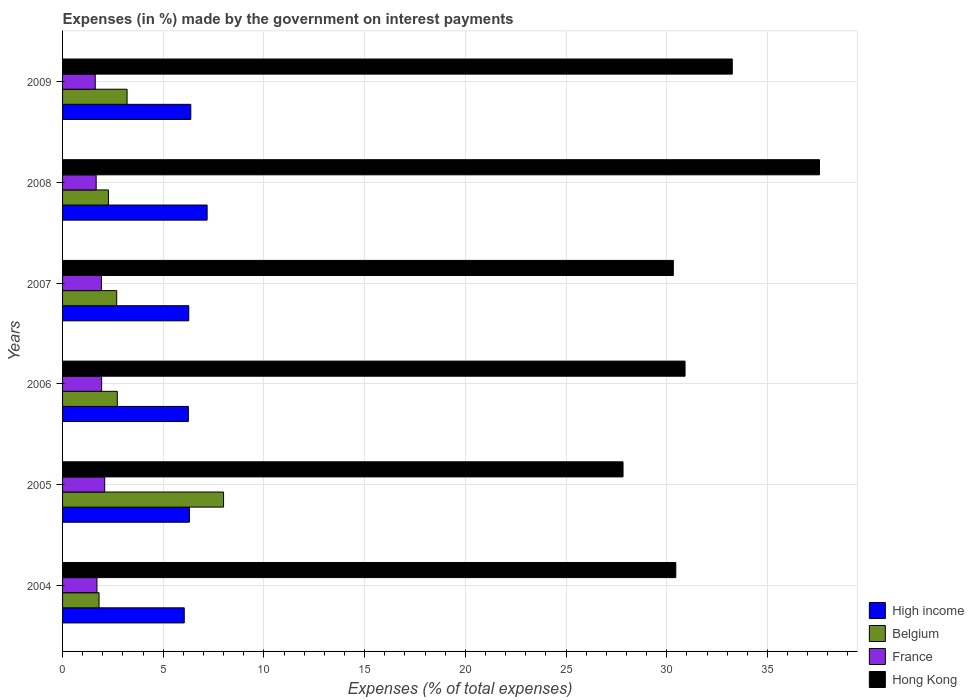Are the number of bars per tick equal to the number of legend labels?
Provide a succinct answer. Yes. How many bars are there on the 5th tick from the top?
Provide a short and direct response. 4. How many bars are there on the 2nd tick from the bottom?
Offer a very short reply. 4. What is the label of the 6th group of bars from the top?
Offer a very short reply. 2004. In how many cases, is the number of bars for a given year not equal to the number of legend labels?
Keep it short and to the point. 0. What is the percentage of expenses made by the government on interest payments in High income in 2004?
Your response must be concise. 6.04. Across all years, what is the maximum percentage of expenses made by the government on interest payments in High income?
Provide a short and direct response. 7.18. Across all years, what is the minimum percentage of expenses made by the government on interest payments in High income?
Keep it short and to the point. 6.04. What is the total percentage of expenses made by the government on interest payments in France in the graph?
Your response must be concise. 10.96. What is the difference between the percentage of expenses made by the government on interest payments in Belgium in 2004 and that in 2007?
Your response must be concise. -0.88. What is the difference between the percentage of expenses made by the government on interest payments in Hong Kong in 2004 and the percentage of expenses made by the government on interest payments in France in 2005?
Ensure brevity in your answer.  28.36. What is the average percentage of expenses made by the government on interest payments in Belgium per year?
Ensure brevity in your answer.  3.45. In the year 2004, what is the difference between the percentage of expenses made by the government on interest payments in High income and percentage of expenses made by the government on interest payments in Belgium?
Your answer should be very brief. 4.23. What is the ratio of the percentage of expenses made by the government on interest payments in High income in 2004 to that in 2006?
Give a very brief answer. 0.97. Is the difference between the percentage of expenses made by the government on interest payments in High income in 2004 and 2006 greater than the difference between the percentage of expenses made by the government on interest payments in Belgium in 2004 and 2006?
Your response must be concise. Yes. What is the difference between the highest and the second highest percentage of expenses made by the government on interest payments in Hong Kong?
Your response must be concise. 4.33. What is the difference between the highest and the lowest percentage of expenses made by the government on interest payments in France?
Provide a succinct answer. 0.47. Is it the case that in every year, the sum of the percentage of expenses made by the government on interest payments in Belgium and percentage of expenses made by the government on interest payments in Hong Kong is greater than the sum of percentage of expenses made by the government on interest payments in High income and percentage of expenses made by the government on interest payments in France?
Offer a very short reply. Yes. What does the 4th bar from the bottom in 2006 represents?
Make the answer very short. Hong Kong. How many bars are there?
Provide a succinct answer. 24. How many years are there in the graph?
Ensure brevity in your answer.  6. What is the difference between two consecutive major ticks on the X-axis?
Your response must be concise. 5. Are the values on the major ticks of X-axis written in scientific E-notation?
Offer a terse response. No. Does the graph contain grids?
Give a very brief answer. Yes. Where does the legend appear in the graph?
Offer a very short reply. Bottom right. How many legend labels are there?
Provide a succinct answer. 4. What is the title of the graph?
Your response must be concise. Expenses (in %) made by the government on interest payments. What is the label or title of the X-axis?
Offer a very short reply. Expenses (% of total expenses). What is the label or title of the Y-axis?
Your response must be concise. Years. What is the Expenses (% of total expenses) of High income in 2004?
Offer a very short reply. 6.04. What is the Expenses (% of total expenses) of Belgium in 2004?
Your response must be concise. 1.81. What is the Expenses (% of total expenses) in France in 2004?
Make the answer very short. 1.71. What is the Expenses (% of total expenses) of Hong Kong in 2004?
Your response must be concise. 30.45. What is the Expenses (% of total expenses) in High income in 2005?
Your answer should be compact. 6.3. What is the Expenses (% of total expenses) in Belgium in 2005?
Your answer should be very brief. 7.99. What is the Expenses (% of total expenses) of France in 2005?
Provide a succinct answer. 2.09. What is the Expenses (% of total expenses) in Hong Kong in 2005?
Your response must be concise. 27.83. What is the Expenses (% of total expenses) in High income in 2006?
Your response must be concise. 6.25. What is the Expenses (% of total expenses) in Belgium in 2006?
Your answer should be very brief. 2.72. What is the Expenses (% of total expenses) in France in 2006?
Ensure brevity in your answer.  1.94. What is the Expenses (% of total expenses) in Hong Kong in 2006?
Keep it short and to the point. 30.91. What is the Expenses (% of total expenses) in High income in 2007?
Offer a very short reply. 6.27. What is the Expenses (% of total expenses) in Belgium in 2007?
Ensure brevity in your answer.  2.69. What is the Expenses (% of total expenses) in France in 2007?
Give a very brief answer. 1.93. What is the Expenses (% of total expenses) in Hong Kong in 2007?
Make the answer very short. 30.33. What is the Expenses (% of total expenses) in High income in 2008?
Keep it short and to the point. 7.18. What is the Expenses (% of total expenses) of Belgium in 2008?
Ensure brevity in your answer.  2.28. What is the Expenses (% of total expenses) in France in 2008?
Provide a succinct answer. 1.67. What is the Expenses (% of total expenses) of Hong Kong in 2008?
Give a very brief answer. 37.59. What is the Expenses (% of total expenses) of High income in 2009?
Make the answer very short. 6.37. What is the Expenses (% of total expenses) of Belgium in 2009?
Offer a very short reply. 3.2. What is the Expenses (% of total expenses) of France in 2009?
Make the answer very short. 1.62. What is the Expenses (% of total expenses) of Hong Kong in 2009?
Provide a succinct answer. 33.26. Across all years, what is the maximum Expenses (% of total expenses) in High income?
Offer a terse response. 7.18. Across all years, what is the maximum Expenses (% of total expenses) in Belgium?
Your answer should be compact. 7.99. Across all years, what is the maximum Expenses (% of total expenses) in France?
Provide a short and direct response. 2.09. Across all years, what is the maximum Expenses (% of total expenses) of Hong Kong?
Offer a terse response. 37.59. Across all years, what is the minimum Expenses (% of total expenses) in High income?
Your answer should be very brief. 6.04. Across all years, what is the minimum Expenses (% of total expenses) of Belgium?
Ensure brevity in your answer.  1.81. Across all years, what is the minimum Expenses (% of total expenses) in France?
Offer a terse response. 1.62. Across all years, what is the minimum Expenses (% of total expenses) in Hong Kong?
Your answer should be very brief. 27.83. What is the total Expenses (% of total expenses) in High income in the graph?
Keep it short and to the point. 38.4. What is the total Expenses (% of total expenses) in Belgium in the graph?
Make the answer very short. 20.69. What is the total Expenses (% of total expenses) of France in the graph?
Your answer should be very brief. 10.96. What is the total Expenses (% of total expenses) of Hong Kong in the graph?
Keep it short and to the point. 190.36. What is the difference between the Expenses (% of total expenses) of High income in 2004 and that in 2005?
Offer a very short reply. -0.26. What is the difference between the Expenses (% of total expenses) of Belgium in 2004 and that in 2005?
Ensure brevity in your answer.  -6.18. What is the difference between the Expenses (% of total expenses) in France in 2004 and that in 2005?
Keep it short and to the point. -0.39. What is the difference between the Expenses (% of total expenses) of Hong Kong in 2004 and that in 2005?
Keep it short and to the point. 2.62. What is the difference between the Expenses (% of total expenses) of High income in 2004 and that in 2006?
Offer a very short reply. -0.2. What is the difference between the Expenses (% of total expenses) in Belgium in 2004 and that in 2006?
Your response must be concise. -0.91. What is the difference between the Expenses (% of total expenses) of France in 2004 and that in 2006?
Your answer should be compact. -0.23. What is the difference between the Expenses (% of total expenses) in Hong Kong in 2004 and that in 2006?
Your answer should be compact. -0.46. What is the difference between the Expenses (% of total expenses) in High income in 2004 and that in 2007?
Make the answer very short. -0.22. What is the difference between the Expenses (% of total expenses) in Belgium in 2004 and that in 2007?
Make the answer very short. -0.88. What is the difference between the Expenses (% of total expenses) in France in 2004 and that in 2007?
Your response must be concise. -0.22. What is the difference between the Expenses (% of total expenses) in Hong Kong in 2004 and that in 2007?
Make the answer very short. 0.12. What is the difference between the Expenses (% of total expenses) in High income in 2004 and that in 2008?
Provide a short and direct response. -1.14. What is the difference between the Expenses (% of total expenses) of Belgium in 2004 and that in 2008?
Keep it short and to the point. -0.47. What is the difference between the Expenses (% of total expenses) of France in 2004 and that in 2008?
Keep it short and to the point. 0.04. What is the difference between the Expenses (% of total expenses) of Hong Kong in 2004 and that in 2008?
Your response must be concise. -7.13. What is the difference between the Expenses (% of total expenses) in High income in 2004 and that in 2009?
Provide a succinct answer. -0.32. What is the difference between the Expenses (% of total expenses) of Belgium in 2004 and that in 2009?
Offer a terse response. -1.39. What is the difference between the Expenses (% of total expenses) of France in 2004 and that in 2009?
Make the answer very short. 0.08. What is the difference between the Expenses (% of total expenses) in Hong Kong in 2004 and that in 2009?
Offer a terse response. -2.8. What is the difference between the Expenses (% of total expenses) of High income in 2005 and that in 2006?
Provide a succinct answer. 0.05. What is the difference between the Expenses (% of total expenses) of Belgium in 2005 and that in 2006?
Give a very brief answer. 5.28. What is the difference between the Expenses (% of total expenses) of France in 2005 and that in 2006?
Offer a very short reply. 0.15. What is the difference between the Expenses (% of total expenses) in Hong Kong in 2005 and that in 2006?
Your answer should be very brief. -3.08. What is the difference between the Expenses (% of total expenses) of High income in 2005 and that in 2007?
Your answer should be compact. 0.03. What is the difference between the Expenses (% of total expenses) in Belgium in 2005 and that in 2007?
Keep it short and to the point. 5.31. What is the difference between the Expenses (% of total expenses) in France in 2005 and that in 2007?
Your answer should be compact. 0.16. What is the difference between the Expenses (% of total expenses) of Hong Kong in 2005 and that in 2007?
Offer a very short reply. -2.5. What is the difference between the Expenses (% of total expenses) of High income in 2005 and that in 2008?
Keep it short and to the point. -0.88. What is the difference between the Expenses (% of total expenses) of Belgium in 2005 and that in 2008?
Offer a terse response. 5.72. What is the difference between the Expenses (% of total expenses) of France in 2005 and that in 2008?
Keep it short and to the point. 0.42. What is the difference between the Expenses (% of total expenses) of Hong Kong in 2005 and that in 2008?
Offer a very short reply. -9.76. What is the difference between the Expenses (% of total expenses) of High income in 2005 and that in 2009?
Keep it short and to the point. -0.07. What is the difference between the Expenses (% of total expenses) of Belgium in 2005 and that in 2009?
Make the answer very short. 4.79. What is the difference between the Expenses (% of total expenses) of France in 2005 and that in 2009?
Your response must be concise. 0.47. What is the difference between the Expenses (% of total expenses) in Hong Kong in 2005 and that in 2009?
Your response must be concise. -5.42. What is the difference between the Expenses (% of total expenses) in High income in 2006 and that in 2007?
Offer a very short reply. -0.02. What is the difference between the Expenses (% of total expenses) of Belgium in 2006 and that in 2007?
Offer a very short reply. 0.03. What is the difference between the Expenses (% of total expenses) in France in 2006 and that in 2007?
Make the answer very short. 0.01. What is the difference between the Expenses (% of total expenses) of Hong Kong in 2006 and that in 2007?
Ensure brevity in your answer.  0.58. What is the difference between the Expenses (% of total expenses) of High income in 2006 and that in 2008?
Offer a terse response. -0.93. What is the difference between the Expenses (% of total expenses) of Belgium in 2006 and that in 2008?
Offer a very short reply. 0.44. What is the difference between the Expenses (% of total expenses) in France in 2006 and that in 2008?
Offer a terse response. 0.27. What is the difference between the Expenses (% of total expenses) of Hong Kong in 2006 and that in 2008?
Make the answer very short. -6.68. What is the difference between the Expenses (% of total expenses) in High income in 2006 and that in 2009?
Your answer should be very brief. -0.12. What is the difference between the Expenses (% of total expenses) of Belgium in 2006 and that in 2009?
Your answer should be very brief. -0.49. What is the difference between the Expenses (% of total expenses) in France in 2006 and that in 2009?
Your answer should be compact. 0.32. What is the difference between the Expenses (% of total expenses) in Hong Kong in 2006 and that in 2009?
Make the answer very short. -2.35. What is the difference between the Expenses (% of total expenses) in High income in 2007 and that in 2008?
Offer a very short reply. -0.91. What is the difference between the Expenses (% of total expenses) in Belgium in 2007 and that in 2008?
Make the answer very short. 0.41. What is the difference between the Expenses (% of total expenses) of France in 2007 and that in 2008?
Offer a terse response. 0.26. What is the difference between the Expenses (% of total expenses) of Hong Kong in 2007 and that in 2008?
Your answer should be compact. -7.26. What is the difference between the Expenses (% of total expenses) of High income in 2007 and that in 2009?
Ensure brevity in your answer.  -0.1. What is the difference between the Expenses (% of total expenses) of Belgium in 2007 and that in 2009?
Your response must be concise. -0.52. What is the difference between the Expenses (% of total expenses) in France in 2007 and that in 2009?
Ensure brevity in your answer.  0.31. What is the difference between the Expenses (% of total expenses) in Hong Kong in 2007 and that in 2009?
Keep it short and to the point. -2.93. What is the difference between the Expenses (% of total expenses) of High income in 2008 and that in 2009?
Ensure brevity in your answer.  0.81. What is the difference between the Expenses (% of total expenses) of Belgium in 2008 and that in 2009?
Your response must be concise. -0.93. What is the difference between the Expenses (% of total expenses) of France in 2008 and that in 2009?
Ensure brevity in your answer.  0.05. What is the difference between the Expenses (% of total expenses) in Hong Kong in 2008 and that in 2009?
Keep it short and to the point. 4.33. What is the difference between the Expenses (% of total expenses) in High income in 2004 and the Expenses (% of total expenses) in Belgium in 2005?
Offer a terse response. -1.95. What is the difference between the Expenses (% of total expenses) of High income in 2004 and the Expenses (% of total expenses) of France in 2005?
Provide a succinct answer. 3.95. What is the difference between the Expenses (% of total expenses) in High income in 2004 and the Expenses (% of total expenses) in Hong Kong in 2005?
Make the answer very short. -21.79. What is the difference between the Expenses (% of total expenses) of Belgium in 2004 and the Expenses (% of total expenses) of France in 2005?
Offer a very short reply. -0.28. What is the difference between the Expenses (% of total expenses) of Belgium in 2004 and the Expenses (% of total expenses) of Hong Kong in 2005?
Give a very brief answer. -26.02. What is the difference between the Expenses (% of total expenses) of France in 2004 and the Expenses (% of total expenses) of Hong Kong in 2005?
Offer a terse response. -26.12. What is the difference between the Expenses (% of total expenses) of High income in 2004 and the Expenses (% of total expenses) of Belgium in 2006?
Provide a succinct answer. 3.32. What is the difference between the Expenses (% of total expenses) of High income in 2004 and the Expenses (% of total expenses) of France in 2006?
Provide a succinct answer. 4.1. What is the difference between the Expenses (% of total expenses) in High income in 2004 and the Expenses (% of total expenses) in Hong Kong in 2006?
Ensure brevity in your answer.  -24.87. What is the difference between the Expenses (% of total expenses) in Belgium in 2004 and the Expenses (% of total expenses) in France in 2006?
Offer a terse response. -0.13. What is the difference between the Expenses (% of total expenses) in Belgium in 2004 and the Expenses (% of total expenses) in Hong Kong in 2006?
Keep it short and to the point. -29.1. What is the difference between the Expenses (% of total expenses) of France in 2004 and the Expenses (% of total expenses) of Hong Kong in 2006?
Offer a terse response. -29.2. What is the difference between the Expenses (% of total expenses) in High income in 2004 and the Expenses (% of total expenses) in Belgium in 2007?
Your answer should be very brief. 3.35. What is the difference between the Expenses (% of total expenses) of High income in 2004 and the Expenses (% of total expenses) of France in 2007?
Offer a very short reply. 4.11. What is the difference between the Expenses (% of total expenses) of High income in 2004 and the Expenses (% of total expenses) of Hong Kong in 2007?
Offer a terse response. -24.29. What is the difference between the Expenses (% of total expenses) in Belgium in 2004 and the Expenses (% of total expenses) in France in 2007?
Your answer should be compact. -0.12. What is the difference between the Expenses (% of total expenses) of Belgium in 2004 and the Expenses (% of total expenses) of Hong Kong in 2007?
Offer a terse response. -28.52. What is the difference between the Expenses (% of total expenses) of France in 2004 and the Expenses (% of total expenses) of Hong Kong in 2007?
Your answer should be compact. -28.62. What is the difference between the Expenses (% of total expenses) in High income in 2004 and the Expenses (% of total expenses) in Belgium in 2008?
Your answer should be very brief. 3.77. What is the difference between the Expenses (% of total expenses) of High income in 2004 and the Expenses (% of total expenses) of France in 2008?
Your response must be concise. 4.37. What is the difference between the Expenses (% of total expenses) in High income in 2004 and the Expenses (% of total expenses) in Hong Kong in 2008?
Your answer should be very brief. -31.54. What is the difference between the Expenses (% of total expenses) in Belgium in 2004 and the Expenses (% of total expenses) in France in 2008?
Offer a terse response. 0.14. What is the difference between the Expenses (% of total expenses) in Belgium in 2004 and the Expenses (% of total expenses) in Hong Kong in 2008?
Offer a very short reply. -35.77. What is the difference between the Expenses (% of total expenses) in France in 2004 and the Expenses (% of total expenses) in Hong Kong in 2008?
Provide a short and direct response. -35.88. What is the difference between the Expenses (% of total expenses) in High income in 2004 and the Expenses (% of total expenses) in Belgium in 2009?
Ensure brevity in your answer.  2.84. What is the difference between the Expenses (% of total expenses) of High income in 2004 and the Expenses (% of total expenses) of France in 2009?
Your answer should be very brief. 4.42. What is the difference between the Expenses (% of total expenses) in High income in 2004 and the Expenses (% of total expenses) in Hong Kong in 2009?
Your answer should be compact. -27.21. What is the difference between the Expenses (% of total expenses) of Belgium in 2004 and the Expenses (% of total expenses) of France in 2009?
Offer a terse response. 0.19. What is the difference between the Expenses (% of total expenses) of Belgium in 2004 and the Expenses (% of total expenses) of Hong Kong in 2009?
Your answer should be compact. -31.44. What is the difference between the Expenses (% of total expenses) in France in 2004 and the Expenses (% of total expenses) in Hong Kong in 2009?
Offer a very short reply. -31.55. What is the difference between the Expenses (% of total expenses) in High income in 2005 and the Expenses (% of total expenses) in Belgium in 2006?
Provide a succinct answer. 3.58. What is the difference between the Expenses (% of total expenses) in High income in 2005 and the Expenses (% of total expenses) in France in 2006?
Provide a short and direct response. 4.36. What is the difference between the Expenses (% of total expenses) of High income in 2005 and the Expenses (% of total expenses) of Hong Kong in 2006?
Your answer should be very brief. -24.61. What is the difference between the Expenses (% of total expenses) of Belgium in 2005 and the Expenses (% of total expenses) of France in 2006?
Make the answer very short. 6.06. What is the difference between the Expenses (% of total expenses) in Belgium in 2005 and the Expenses (% of total expenses) in Hong Kong in 2006?
Give a very brief answer. -22.92. What is the difference between the Expenses (% of total expenses) in France in 2005 and the Expenses (% of total expenses) in Hong Kong in 2006?
Keep it short and to the point. -28.82. What is the difference between the Expenses (% of total expenses) of High income in 2005 and the Expenses (% of total expenses) of Belgium in 2007?
Offer a terse response. 3.61. What is the difference between the Expenses (% of total expenses) of High income in 2005 and the Expenses (% of total expenses) of France in 2007?
Ensure brevity in your answer.  4.37. What is the difference between the Expenses (% of total expenses) of High income in 2005 and the Expenses (% of total expenses) of Hong Kong in 2007?
Provide a short and direct response. -24.03. What is the difference between the Expenses (% of total expenses) in Belgium in 2005 and the Expenses (% of total expenses) in France in 2007?
Make the answer very short. 6.07. What is the difference between the Expenses (% of total expenses) of Belgium in 2005 and the Expenses (% of total expenses) of Hong Kong in 2007?
Provide a succinct answer. -22.33. What is the difference between the Expenses (% of total expenses) in France in 2005 and the Expenses (% of total expenses) in Hong Kong in 2007?
Keep it short and to the point. -28.23. What is the difference between the Expenses (% of total expenses) of High income in 2005 and the Expenses (% of total expenses) of Belgium in 2008?
Give a very brief answer. 4.02. What is the difference between the Expenses (% of total expenses) in High income in 2005 and the Expenses (% of total expenses) in France in 2008?
Ensure brevity in your answer.  4.63. What is the difference between the Expenses (% of total expenses) of High income in 2005 and the Expenses (% of total expenses) of Hong Kong in 2008?
Provide a short and direct response. -31.29. What is the difference between the Expenses (% of total expenses) of Belgium in 2005 and the Expenses (% of total expenses) of France in 2008?
Your answer should be very brief. 6.33. What is the difference between the Expenses (% of total expenses) in Belgium in 2005 and the Expenses (% of total expenses) in Hong Kong in 2008?
Your answer should be compact. -29.59. What is the difference between the Expenses (% of total expenses) of France in 2005 and the Expenses (% of total expenses) of Hong Kong in 2008?
Your answer should be very brief. -35.49. What is the difference between the Expenses (% of total expenses) of High income in 2005 and the Expenses (% of total expenses) of Belgium in 2009?
Ensure brevity in your answer.  3.1. What is the difference between the Expenses (% of total expenses) in High income in 2005 and the Expenses (% of total expenses) in France in 2009?
Keep it short and to the point. 4.68. What is the difference between the Expenses (% of total expenses) in High income in 2005 and the Expenses (% of total expenses) in Hong Kong in 2009?
Keep it short and to the point. -26.95. What is the difference between the Expenses (% of total expenses) in Belgium in 2005 and the Expenses (% of total expenses) in France in 2009?
Provide a short and direct response. 6.37. What is the difference between the Expenses (% of total expenses) of Belgium in 2005 and the Expenses (% of total expenses) of Hong Kong in 2009?
Offer a very short reply. -25.26. What is the difference between the Expenses (% of total expenses) of France in 2005 and the Expenses (% of total expenses) of Hong Kong in 2009?
Offer a very short reply. -31.16. What is the difference between the Expenses (% of total expenses) of High income in 2006 and the Expenses (% of total expenses) of Belgium in 2007?
Keep it short and to the point. 3.56. What is the difference between the Expenses (% of total expenses) of High income in 2006 and the Expenses (% of total expenses) of France in 2007?
Provide a short and direct response. 4.32. What is the difference between the Expenses (% of total expenses) of High income in 2006 and the Expenses (% of total expenses) of Hong Kong in 2007?
Ensure brevity in your answer.  -24.08. What is the difference between the Expenses (% of total expenses) of Belgium in 2006 and the Expenses (% of total expenses) of France in 2007?
Offer a very short reply. 0.79. What is the difference between the Expenses (% of total expenses) in Belgium in 2006 and the Expenses (% of total expenses) in Hong Kong in 2007?
Your answer should be compact. -27.61. What is the difference between the Expenses (% of total expenses) of France in 2006 and the Expenses (% of total expenses) of Hong Kong in 2007?
Your answer should be very brief. -28.39. What is the difference between the Expenses (% of total expenses) in High income in 2006 and the Expenses (% of total expenses) in Belgium in 2008?
Give a very brief answer. 3.97. What is the difference between the Expenses (% of total expenses) in High income in 2006 and the Expenses (% of total expenses) in France in 2008?
Provide a short and direct response. 4.58. What is the difference between the Expenses (% of total expenses) in High income in 2006 and the Expenses (% of total expenses) in Hong Kong in 2008?
Keep it short and to the point. -31.34. What is the difference between the Expenses (% of total expenses) in Belgium in 2006 and the Expenses (% of total expenses) in France in 2008?
Provide a short and direct response. 1.05. What is the difference between the Expenses (% of total expenses) of Belgium in 2006 and the Expenses (% of total expenses) of Hong Kong in 2008?
Provide a short and direct response. -34.87. What is the difference between the Expenses (% of total expenses) of France in 2006 and the Expenses (% of total expenses) of Hong Kong in 2008?
Offer a terse response. -35.65. What is the difference between the Expenses (% of total expenses) of High income in 2006 and the Expenses (% of total expenses) of Belgium in 2009?
Your response must be concise. 3.04. What is the difference between the Expenses (% of total expenses) of High income in 2006 and the Expenses (% of total expenses) of France in 2009?
Ensure brevity in your answer.  4.62. What is the difference between the Expenses (% of total expenses) in High income in 2006 and the Expenses (% of total expenses) in Hong Kong in 2009?
Ensure brevity in your answer.  -27.01. What is the difference between the Expenses (% of total expenses) in Belgium in 2006 and the Expenses (% of total expenses) in France in 2009?
Offer a very short reply. 1.1. What is the difference between the Expenses (% of total expenses) in Belgium in 2006 and the Expenses (% of total expenses) in Hong Kong in 2009?
Provide a succinct answer. -30.54. What is the difference between the Expenses (% of total expenses) of France in 2006 and the Expenses (% of total expenses) of Hong Kong in 2009?
Provide a succinct answer. -31.32. What is the difference between the Expenses (% of total expenses) in High income in 2007 and the Expenses (% of total expenses) in Belgium in 2008?
Your response must be concise. 3.99. What is the difference between the Expenses (% of total expenses) in High income in 2007 and the Expenses (% of total expenses) in France in 2008?
Provide a short and direct response. 4.6. What is the difference between the Expenses (% of total expenses) in High income in 2007 and the Expenses (% of total expenses) in Hong Kong in 2008?
Make the answer very short. -31.32. What is the difference between the Expenses (% of total expenses) of Belgium in 2007 and the Expenses (% of total expenses) of France in 2008?
Your answer should be very brief. 1.02. What is the difference between the Expenses (% of total expenses) in Belgium in 2007 and the Expenses (% of total expenses) in Hong Kong in 2008?
Offer a very short reply. -34.9. What is the difference between the Expenses (% of total expenses) in France in 2007 and the Expenses (% of total expenses) in Hong Kong in 2008?
Ensure brevity in your answer.  -35.66. What is the difference between the Expenses (% of total expenses) in High income in 2007 and the Expenses (% of total expenses) in Belgium in 2009?
Your response must be concise. 3.06. What is the difference between the Expenses (% of total expenses) in High income in 2007 and the Expenses (% of total expenses) in France in 2009?
Offer a very short reply. 4.64. What is the difference between the Expenses (% of total expenses) in High income in 2007 and the Expenses (% of total expenses) in Hong Kong in 2009?
Offer a terse response. -26.99. What is the difference between the Expenses (% of total expenses) of Belgium in 2007 and the Expenses (% of total expenses) of France in 2009?
Your answer should be very brief. 1.07. What is the difference between the Expenses (% of total expenses) of Belgium in 2007 and the Expenses (% of total expenses) of Hong Kong in 2009?
Provide a succinct answer. -30.57. What is the difference between the Expenses (% of total expenses) in France in 2007 and the Expenses (% of total expenses) in Hong Kong in 2009?
Your answer should be compact. -31.33. What is the difference between the Expenses (% of total expenses) in High income in 2008 and the Expenses (% of total expenses) in Belgium in 2009?
Ensure brevity in your answer.  3.98. What is the difference between the Expenses (% of total expenses) of High income in 2008 and the Expenses (% of total expenses) of France in 2009?
Your answer should be very brief. 5.56. What is the difference between the Expenses (% of total expenses) in High income in 2008 and the Expenses (% of total expenses) in Hong Kong in 2009?
Make the answer very short. -26.08. What is the difference between the Expenses (% of total expenses) in Belgium in 2008 and the Expenses (% of total expenses) in France in 2009?
Offer a very short reply. 0.65. What is the difference between the Expenses (% of total expenses) of Belgium in 2008 and the Expenses (% of total expenses) of Hong Kong in 2009?
Offer a terse response. -30.98. What is the difference between the Expenses (% of total expenses) in France in 2008 and the Expenses (% of total expenses) in Hong Kong in 2009?
Offer a very short reply. -31.59. What is the average Expenses (% of total expenses) in High income per year?
Keep it short and to the point. 6.4. What is the average Expenses (% of total expenses) in Belgium per year?
Your response must be concise. 3.45. What is the average Expenses (% of total expenses) of France per year?
Give a very brief answer. 1.83. What is the average Expenses (% of total expenses) of Hong Kong per year?
Your answer should be compact. 31.73. In the year 2004, what is the difference between the Expenses (% of total expenses) in High income and Expenses (% of total expenses) in Belgium?
Provide a succinct answer. 4.23. In the year 2004, what is the difference between the Expenses (% of total expenses) of High income and Expenses (% of total expenses) of France?
Keep it short and to the point. 4.34. In the year 2004, what is the difference between the Expenses (% of total expenses) of High income and Expenses (% of total expenses) of Hong Kong?
Offer a very short reply. -24.41. In the year 2004, what is the difference between the Expenses (% of total expenses) in Belgium and Expenses (% of total expenses) in France?
Provide a short and direct response. 0.11. In the year 2004, what is the difference between the Expenses (% of total expenses) in Belgium and Expenses (% of total expenses) in Hong Kong?
Keep it short and to the point. -28.64. In the year 2004, what is the difference between the Expenses (% of total expenses) of France and Expenses (% of total expenses) of Hong Kong?
Make the answer very short. -28.74. In the year 2005, what is the difference between the Expenses (% of total expenses) in High income and Expenses (% of total expenses) in Belgium?
Your answer should be very brief. -1.69. In the year 2005, what is the difference between the Expenses (% of total expenses) in High income and Expenses (% of total expenses) in France?
Your answer should be compact. 4.21. In the year 2005, what is the difference between the Expenses (% of total expenses) of High income and Expenses (% of total expenses) of Hong Kong?
Offer a very short reply. -21.53. In the year 2005, what is the difference between the Expenses (% of total expenses) of Belgium and Expenses (% of total expenses) of France?
Make the answer very short. 5.9. In the year 2005, what is the difference between the Expenses (% of total expenses) of Belgium and Expenses (% of total expenses) of Hong Kong?
Provide a succinct answer. -19.84. In the year 2005, what is the difference between the Expenses (% of total expenses) of France and Expenses (% of total expenses) of Hong Kong?
Keep it short and to the point. -25.74. In the year 2006, what is the difference between the Expenses (% of total expenses) of High income and Expenses (% of total expenses) of Belgium?
Offer a very short reply. 3.53. In the year 2006, what is the difference between the Expenses (% of total expenses) in High income and Expenses (% of total expenses) in France?
Provide a succinct answer. 4.31. In the year 2006, what is the difference between the Expenses (% of total expenses) in High income and Expenses (% of total expenses) in Hong Kong?
Provide a succinct answer. -24.66. In the year 2006, what is the difference between the Expenses (% of total expenses) in Belgium and Expenses (% of total expenses) in France?
Give a very brief answer. 0.78. In the year 2006, what is the difference between the Expenses (% of total expenses) in Belgium and Expenses (% of total expenses) in Hong Kong?
Offer a very short reply. -28.19. In the year 2006, what is the difference between the Expenses (% of total expenses) in France and Expenses (% of total expenses) in Hong Kong?
Offer a terse response. -28.97. In the year 2007, what is the difference between the Expenses (% of total expenses) in High income and Expenses (% of total expenses) in Belgium?
Your answer should be very brief. 3.58. In the year 2007, what is the difference between the Expenses (% of total expenses) in High income and Expenses (% of total expenses) in France?
Make the answer very short. 4.34. In the year 2007, what is the difference between the Expenses (% of total expenses) in High income and Expenses (% of total expenses) in Hong Kong?
Your answer should be very brief. -24.06. In the year 2007, what is the difference between the Expenses (% of total expenses) of Belgium and Expenses (% of total expenses) of France?
Keep it short and to the point. 0.76. In the year 2007, what is the difference between the Expenses (% of total expenses) of Belgium and Expenses (% of total expenses) of Hong Kong?
Offer a terse response. -27.64. In the year 2007, what is the difference between the Expenses (% of total expenses) in France and Expenses (% of total expenses) in Hong Kong?
Keep it short and to the point. -28.4. In the year 2008, what is the difference between the Expenses (% of total expenses) of High income and Expenses (% of total expenses) of Belgium?
Your response must be concise. 4.9. In the year 2008, what is the difference between the Expenses (% of total expenses) of High income and Expenses (% of total expenses) of France?
Your answer should be compact. 5.51. In the year 2008, what is the difference between the Expenses (% of total expenses) of High income and Expenses (% of total expenses) of Hong Kong?
Offer a very short reply. -30.41. In the year 2008, what is the difference between the Expenses (% of total expenses) in Belgium and Expenses (% of total expenses) in France?
Provide a succinct answer. 0.61. In the year 2008, what is the difference between the Expenses (% of total expenses) in Belgium and Expenses (% of total expenses) in Hong Kong?
Your answer should be very brief. -35.31. In the year 2008, what is the difference between the Expenses (% of total expenses) in France and Expenses (% of total expenses) in Hong Kong?
Provide a succinct answer. -35.92. In the year 2009, what is the difference between the Expenses (% of total expenses) of High income and Expenses (% of total expenses) of Belgium?
Give a very brief answer. 3.16. In the year 2009, what is the difference between the Expenses (% of total expenses) in High income and Expenses (% of total expenses) in France?
Make the answer very short. 4.74. In the year 2009, what is the difference between the Expenses (% of total expenses) in High income and Expenses (% of total expenses) in Hong Kong?
Make the answer very short. -26.89. In the year 2009, what is the difference between the Expenses (% of total expenses) in Belgium and Expenses (% of total expenses) in France?
Provide a succinct answer. 1.58. In the year 2009, what is the difference between the Expenses (% of total expenses) in Belgium and Expenses (% of total expenses) in Hong Kong?
Ensure brevity in your answer.  -30.05. In the year 2009, what is the difference between the Expenses (% of total expenses) in France and Expenses (% of total expenses) in Hong Kong?
Keep it short and to the point. -31.63. What is the ratio of the Expenses (% of total expenses) of High income in 2004 to that in 2005?
Give a very brief answer. 0.96. What is the ratio of the Expenses (% of total expenses) in Belgium in 2004 to that in 2005?
Ensure brevity in your answer.  0.23. What is the ratio of the Expenses (% of total expenses) in France in 2004 to that in 2005?
Ensure brevity in your answer.  0.82. What is the ratio of the Expenses (% of total expenses) in Hong Kong in 2004 to that in 2005?
Keep it short and to the point. 1.09. What is the ratio of the Expenses (% of total expenses) of High income in 2004 to that in 2006?
Provide a short and direct response. 0.97. What is the ratio of the Expenses (% of total expenses) of Belgium in 2004 to that in 2006?
Keep it short and to the point. 0.67. What is the ratio of the Expenses (% of total expenses) of France in 2004 to that in 2006?
Provide a short and direct response. 0.88. What is the ratio of the Expenses (% of total expenses) of Hong Kong in 2004 to that in 2006?
Make the answer very short. 0.99. What is the ratio of the Expenses (% of total expenses) of High income in 2004 to that in 2007?
Your answer should be very brief. 0.96. What is the ratio of the Expenses (% of total expenses) in Belgium in 2004 to that in 2007?
Offer a terse response. 0.67. What is the ratio of the Expenses (% of total expenses) in France in 2004 to that in 2007?
Provide a short and direct response. 0.88. What is the ratio of the Expenses (% of total expenses) in Hong Kong in 2004 to that in 2007?
Keep it short and to the point. 1. What is the ratio of the Expenses (% of total expenses) in High income in 2004 to that in 2008?
Ensure brevity in your answer.  0.84. What is the ratio of the Expenses (% of total expenses) of Belgium in 2004 to that in 2008?
Your response must be concise. 0.8. What is the ratio of the Expenses (% of total expenses) in France in 2004 to that in 2008?
Keep it short and to the point. 1.02. What is the ratio of the Expenses (% of total expenses) of Hong Kong in 2004 to that in 2008?
Your response must be concise. 0.81. What is the ratio of the Expenses (% of total expenses) of High income in 2004 to that in 2009?
Provide a succinct answer. 0.95. What is the ratio of the Expenses (% of total expenses) of Belgium in 2004 to that in 2009?
Offer a terse response. 0.57. What is the ratio of the Expenses (% of total expenses) in France in 2004 to that in 2009?
Ensure brevity in your answer.  1.05. What is the ratio of the Expenses (% of total expenses) of Hong Kong in 2004 to that in 2009?
Ensure brevity in your answer.  0.92. What is the ratio of the Expenses (% of total expenses) in High income in 2005 to that in 2006?
Offer a terse response. 1.01. What is the ratio of the Expenses (% of total expenses) of Belgium in 2005 to that in 2006?
Your answer should be compact. 2.94. What is the ratio of the Expenses (% of total expenses) of France in 2005 to that in 2006?
Offer a very short reply. 1.08. What is the ratio of the Expenses (% of total expenses) of Hong Kong in 2005 to that in 2006?
Your response must be concise. 0.9. What is the ratio of the Expenses (% of total expenses) of High income in 2005 to that in 2007?
Ensure brevity in your answer.  1.01. What is the ratio of the Expenses (% of total expenses) of Belgium in 2005 to that in 2007?
Give a very brief answer. 2.97. What is the ratio of the Expenses (% of total expenses) in France in 2005 to that in 2007?
Offer a terse response. 1.08. What is the ratio of the Expenses (% of total expenses) of Hong Kong in 2005 to that in 2007?
Your answer should be very brief. 0.92. What is the ratio of the Expenses (% of total expenses) in High income in 2005 to that in 2008?
Offer a terse response. 0.88. What is the ratio of the Expenses (% of total expenses) in Belgium in 2005 to that in 2008?
Offer a terse response. 3.51. What is the ratio of the Expenses (% of total expenses) in France in 2005 to that in 2008?
Ensure brevity in your answer.  1.25. What is the ratio of the Expenses (% of total expenses) in Hong Kong in 2005 to that in 2008?
Ensure brevity in your answer.  0.74. What is the ratio of the Expenses (% of total expenses) in High income in 2005 to that in 2009?
Your response must be concise. 0.99. What is the ratio of the Expenses (% of total expenses) in Belgium in 2005 to that in 2009?
Offer a terse response. 2.5. What is the ratio of the Expenses (% of total expenses) in France in 2005 to that in 2009?
Offer a terse response. 1.29. What is the ratio of the Expenses (% of total expenses) of Hong Kong in 2005 to that in 2009?
Your answer should be very brief. 0.84. What is the ratio of the Expenses (% of total expenses) in High income in 2006 to that in 2007?
Your answer should be compact. 1. What is the ratio of the Expenses (% of total expenses) of Belgium in 2006 to that in 2007?
Make the answer very short. 1.01. What is the ratio of the Expenses (% of total expenses) of France in 2006 to that in 2007?
Keep it short and to the point. 1.01. What is the ratio of the Expenses (% of total expenses) of Hong Kong in 2006 to that in 2007?
Provide a short and direct response. 1.02. What is the ratio of the Expenses (% of total expenses) in High income in 2006 to that in 2008?
Your response must be concise. 0.87. What is the ratio of the Expenses (% of total expenses) of Belgium in 2006 to that in 2008?
Make the answer very short. 1.19. What is the ratio of the Expenses (% of total expenses) in France in 2006 to that in 2008?
Make the answer very short. 1.16. What is the ratio of the Expenses (% of total expenses) of Hong Kong in 2006 to that in 2008?
Ensure brevity in your answer.  0.82. What is the ratio of the Expenses (% of total expenses) in Belgium in 2006 to that in 2009?
Offer a terse response. 0.85. What is the ratio of the Expenses (% of total expenses) of France in 2006 to that in 2009?
Provide a short and direct response. 1.19. What is the ratio of the Expenses (% of total expenses) of Hong Kong in 2006 to that in 2009?
Ensure brevity in your answer.  0.93. What is the ratio of the Expenses (% of total expenses) of High income in 2007 to that in 2008?
Your response must be concise. 0.87. What is the ratio of the Expenses (% of total expenses) of Belgium in 2007 to that in 2008?
Provide a short and direct response. 1.18. What is the ratio of the Expenses (% of total expenses) in France in 2007 to that in 2008?
Make the answer very short. 1.16. What is the ratio of the Expenses (% of total expenses) in Hong Kong in 2007 to that in 2008?
Offer a terse response. 0.81. What is the ratio of the Expenses (% of total expenses) in High income in 2007 to that in 2009?
Offer a terse response. 0.98. What is the ratio of the Expenses (% of total expenses) of Belgium in 2007 to that in 2009?
Provide a short and direct response. 0.84. What is the ratio of the Expenses (% of total expenses) in France in 2007 to that in 2009?
Keep it short and to the point. 1.19. What is the ratio of the Expenses (% of total expenses) of Hong Kong in 2007 to that in 2009?
Make the answer very short. 0.91. What is the ratio of the Expenses (% of total expenses) of High income in 2008 to that in 2009?
Make the answer very short. 1.13. What is the ratio of the Expenses (% of total expenses) in Belgium in 2008 to that in 2009?
Provide a succinct answer. 0.71. What is the ratio of the Expenses (% of total expenses) in France in 2008 to that in 2009?
Provide a succinct answer. 1.03. What is the ratio of the Expenses (% of total expenses) of Hong Kong in 2008 to that in 2009?
Your response must be concise. 1.13. What is the difference between the highest and the second highest Expenses (% of total expenses) in High income?
Provide a succinct answer. 0.81. What is the difference between the highest and the second highest Expenses (% of total expenses) of Belgium?
Make the answer very short. 4.79. What is the difference between the highest and the second highest Expenses (% of total expenses) of France?
Your answer should be very brief. 0.15. What is the difference between the highest and the second highest Expenses (% of total expenses) of Hong Kong?
Offer a very short reply. 4.33. What is the difference between the highest and the lowest Expenses (% of total expenses) of High income?
Provide a short and direct response. 1.14. What is the difference between the highest and the lowest Expenses (% of total expenses) of Belgium?
Give a very brief answer. 6.18. What is the difference between the highest and the lowest Expenses (% of total expenses) in France?
Offer a very short reply. 0.47. What is the difference between the highest and the lowest Expenses (% of total expenses) in Hong Kong?
Ensure brevity in your answer.  9.76. 